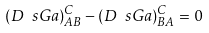Convert formula to latex. <formula><loc_0><loc_0><loc_500><loc_500>( D \ s G a ) ^ { C } _ { A B } - ( D \ s G a ) ^ { C } _ { B A } = 0</formula> 